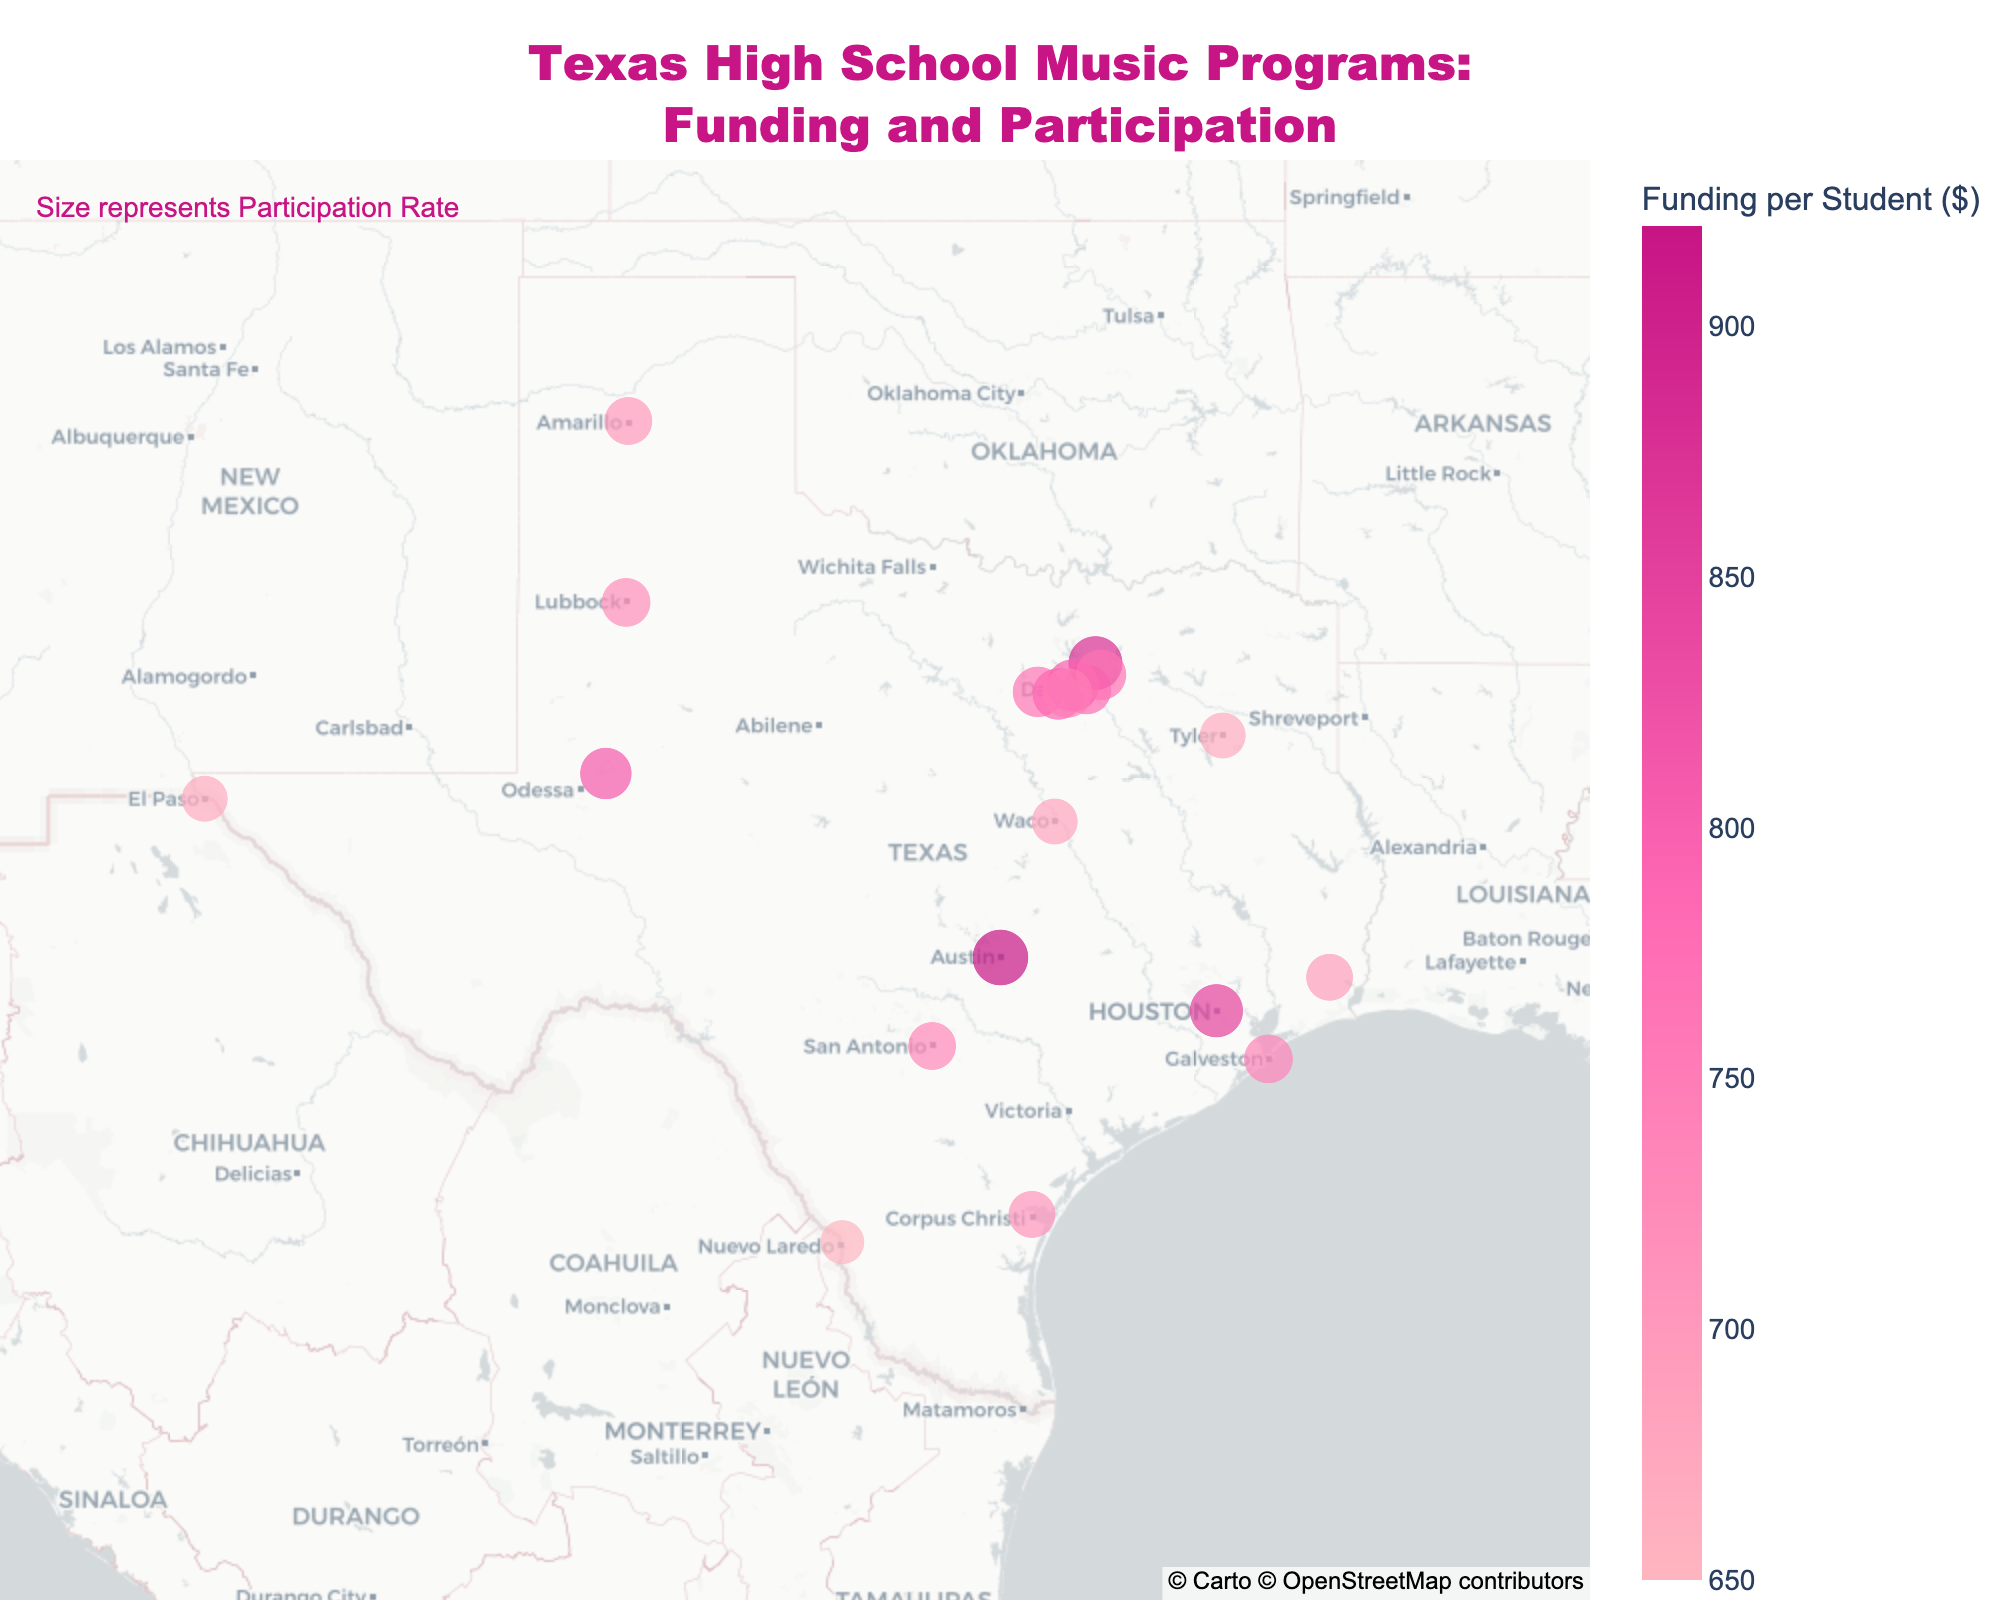How many cities are represented on the plot? Counting all the distinct data points or markers representing different cities on the plot gives us the total number of cities. From the data, we know there are distinct data points for each city listed.
Answer: 19 What city has the highest funding per student? By examining the color gradient on the plot, which represents funding levels, we identify the city with the darkest color indicating the highest funding. Specifically, Austin has the highest funding per student at $920.
Answer: Austin Which city has the lowest participation rate in music programs? By reviewing the size of the markers, which represent the participation rates, we identify the smallest marker on the plot. Laredo has the smallest marker, indicating the lowest participation rate of 22%.
Answer: Laredo What specific information is shown when you hover over a city marker? When hovering over a marker, typically the city name, funding per student, and participation rate appear as details. For instance, hovering over Houston shows "City: Houston, Funding per Student: $850, Participation Rate: 32%".
Answer: City name, Funding per Student, Participation Rate What is the difference in funding per student between Austin and San Antonio? Austin has a funding per student of $920, while San Antonio has $730. The difference is calculated as $920 - $730.
Answer: $190 Which city has both high funding per student and high participation in music programs? We look for cities with larger markers (higher participation) and darker colors (higher funding). Plano and Austin have both high funding levels and high participation rates, with Austin having $920 funding and 35% participation, and Plano having $880 funding and 33% participation.
Answer: Austin and Plano How does the participation rate in Houston compare to that in Dallas? According to the data, Houston has a participation rate of 32%, while Dallas has a rate of 28%. Comparing these rates, Houston's participation is higher than Dallas'.
Answer: Houston has a higher participation rate Which city has the closest participation rate to an average of 30% and also has funding per student above $800? First, estimate the average with values close to 30%, then checking the funding levels above $800. We find that Houston has a participation rate of 32% and a funding per student of $850.
Answer: Houston What can one infer about the city of El Paso based on its marker's size and color? El Paso is represented by a marker indicating both its participation rate and funding level. Its smaller marker and lighter color suggest it has lower participation (24%) and lower funding ($670) compared to other cities.
Answer: El Paso has lower participation and funding Which cities have similar funding levels but different participation rates? Observing markers with similar colors (funding levels) but different sizes (participation rates), Irving and Garland both have funding around $800 ($800 and $770 respectively), yet their participation rates differ (31% and 29% respectively).
Answer: Irving and Garland 